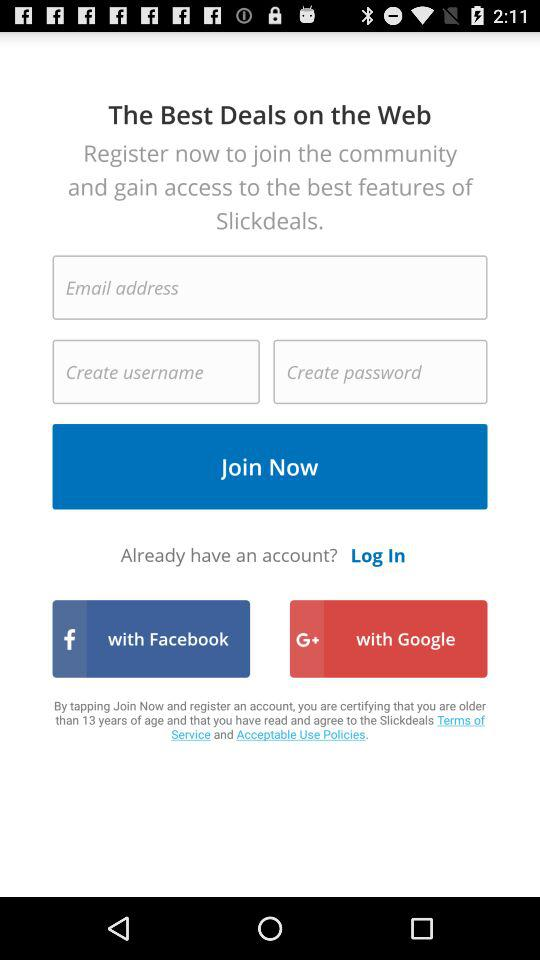How many fields are required to create an account?
Answer the question using a single word or phrase. 3 